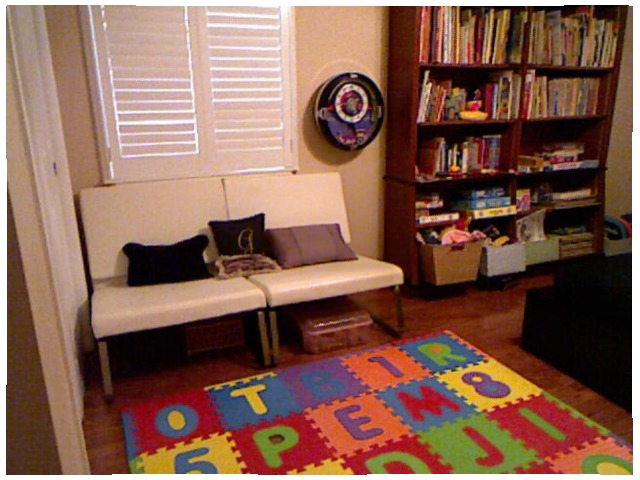<image>
Is the file under the chair? No. The file is not positioned under the chair. The vertical relationship between these objects is different. Is there a book on the shelf? Yes. Looking at the image, I can see the book is positioned on top of the shelf, with the shelf providing support. Is the letter on the floor? Yes. Looking at the image, I can see the letter is positioned on top of the floor, with the floor providing support. Where is the pillow in relation to the chair? Is it on the chair? No. The pillow is not positioned on the chair. They may be near each other, but the pillow is not supported by or resting on top of the chair. Is there a clock behind the sofa? Yes. From this viewpoint, the clock is positioned behind the sofa, with the sofa partially or fully occluding the clock. Is the pillow behind the plastic box? No. The pillow is not behind the plastic box. From this viewpoint, the pillow appears to be positioned elsewhere in the scene. Is there a floor mat to the right of the blinds? No. The floor mat is not to the right of the blinds. The horizontal positioning shows a different relationship. 